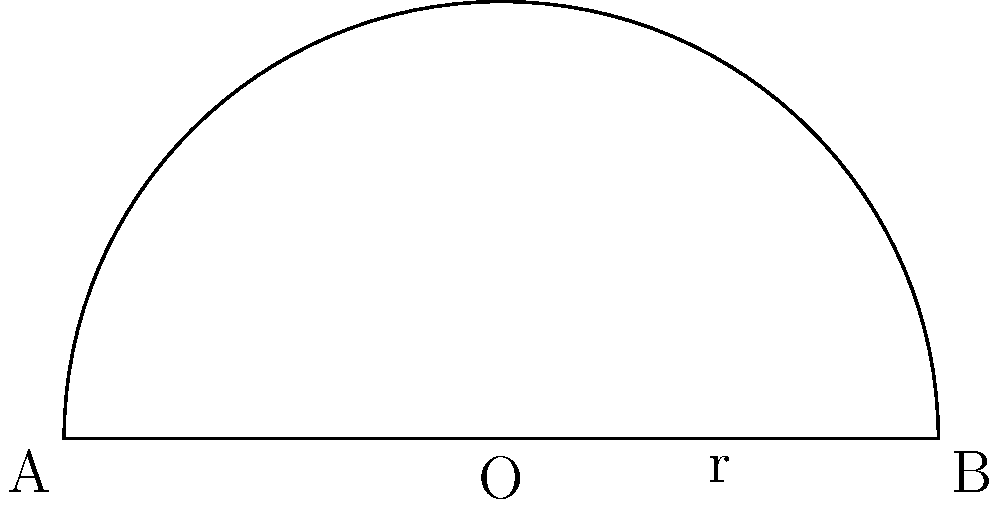As a horse breeder, you're designing a new semi-circular pasture for your prized stallions. The pasture has a radius of 50 meters and needs to be enclosed by a curved fence along its arc. How many meters of fencing material do you need to purchase to construct this curved portion of the enclosure? Let's approach this step-by-step:

1) The pasture is semi-circular, which means it forms half of a complete circle.

2) The formula for the circumference of a full circle is:
   $$C = 2\pi r$$
   where $r$ is the radius.

3) Since we only need half of this (the semi-circle), we'll divide this formula by 2:
   $$L = \frac{1}{2} \cdot 2\pi r = \pi r$$
   where $L$ is the length of the curved fence.

4) We're given that the radius $r = 50$ meters.

5) Substituting this into our formula:
   $$L = \pi \cdot 50$$

6) $\pi$ is approximately 3.14159, so:
   $$L \approx 3.14159 \cdot 50 = 157.0795$$

7) Rounding to the nearest meter (as it's practical for fencing):
   $$L \approx 157 \text{ meters}$$

Therefore, you'll need approximately 157 meters of fencing material for the curved portion of your semi-circular pasture.
Answer: 157 meters 